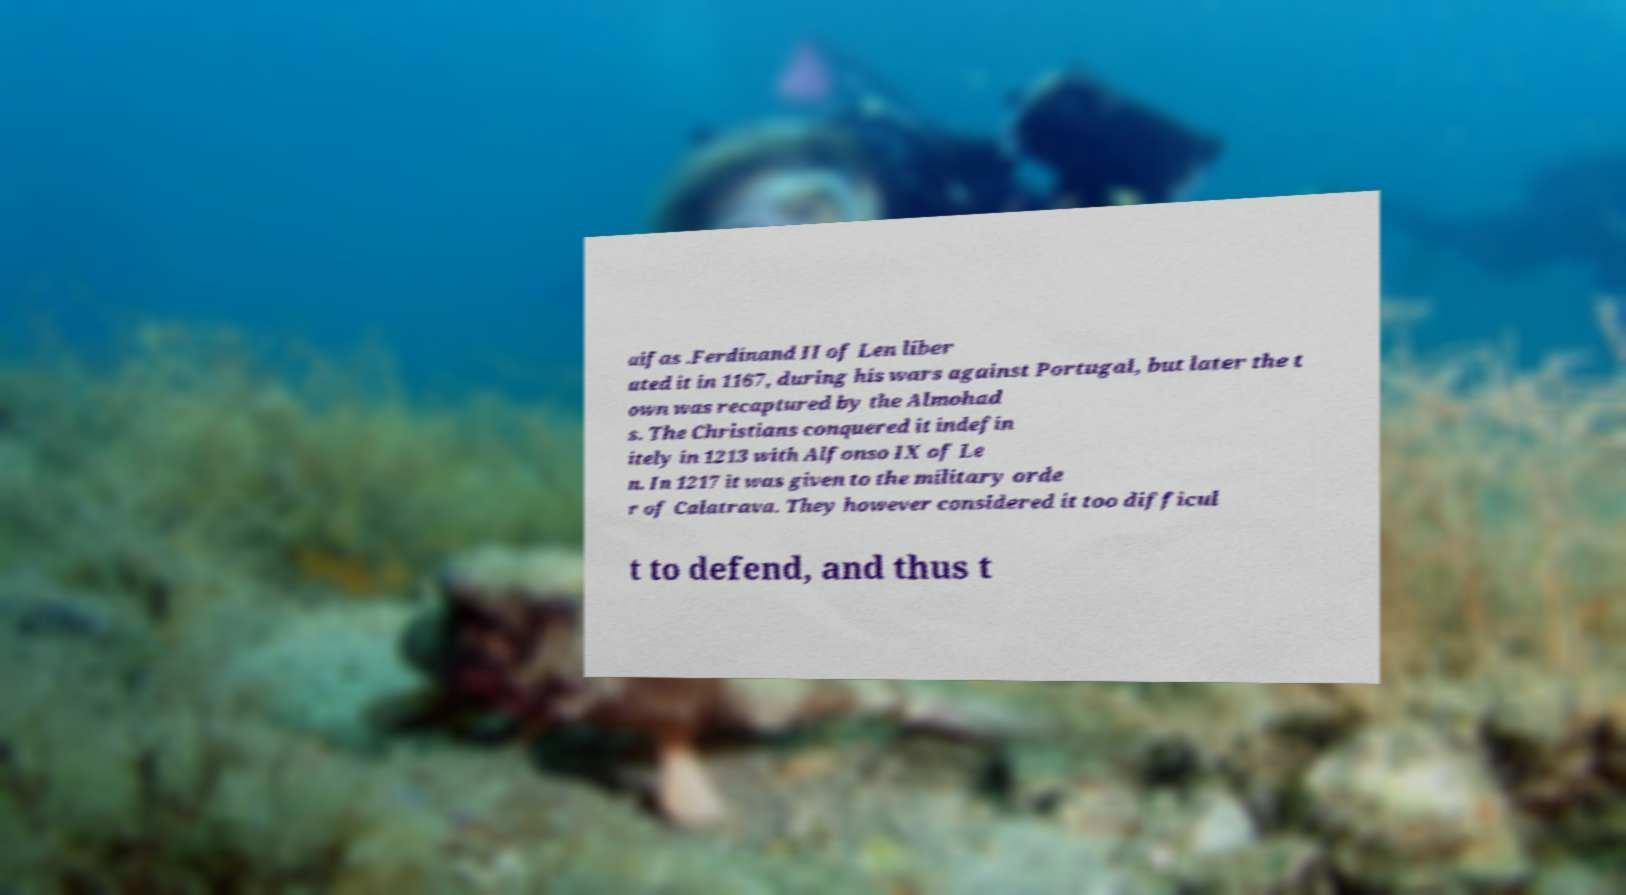I need the written content from this picture converted into text. Can you do that? aifas .Ferdinand II of Len liber ated it in 1167, during his wars against Portugal, but later the t own was recaptured by the Almohad s. The Christians conquered it indefin itely in 1213 with Alfonso IX of Le n. In 1217 it was given to the military orde r of Calatrava. They however considered it too difficul t to defend, and thus t 